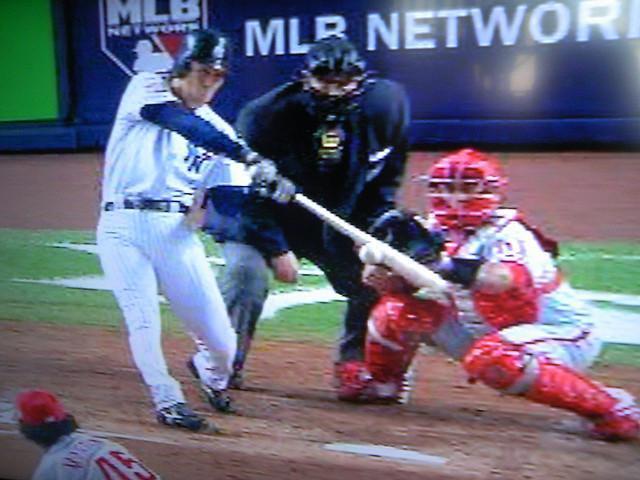How many people are there?
Give a very brief answer. 4. 